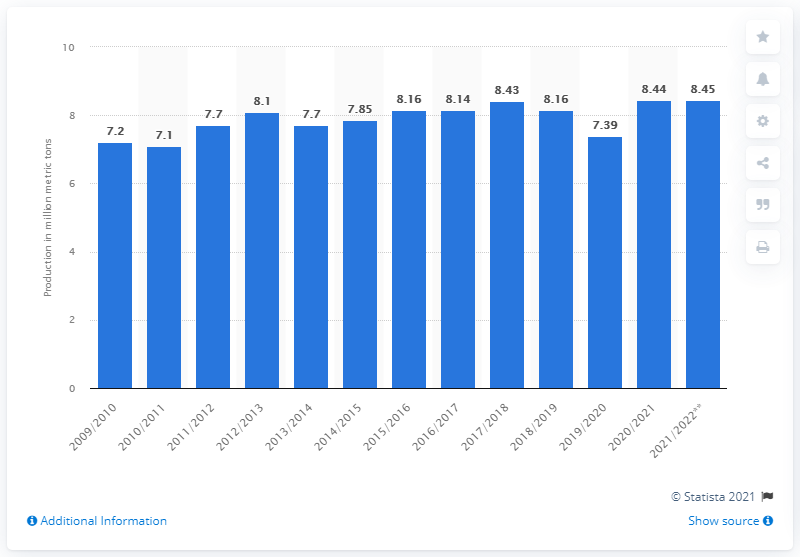Specify some key components in this picture. In 2009/2010, the United States produced approximately 7.2 million metric tons of sugar. 